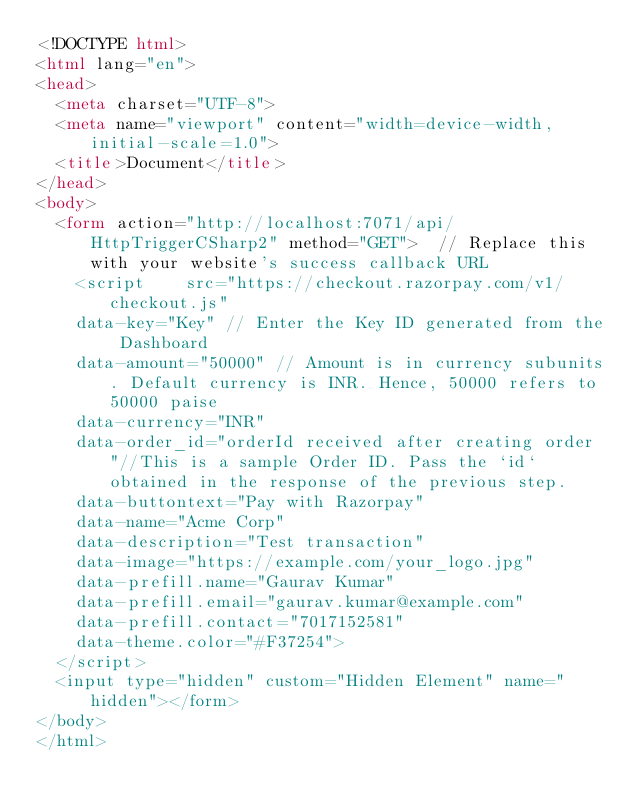Convert code to text. <code><loc_0><loc_0><loc_500><loc_500><_HTML_><!DOCTYPE html>
<html lang="en">
<head>
  <meta charset="UTF-8">
  <meta name="viewport" content="width=device-width, initial-scale=1.0">
  <title>Document</title>
</head>
<body>
  <form action="http://localhost:7071/api/HttpTriggerCSharp2" method="GET">  // Replace this with your website's success callback URL
    <script    src="https://checkout.razorpay.com/v1/checkout.js"    
    data-key="Key" // Enter the Key ID generated from the Dashboard    
    data-amount="50000" // Amount is in currency subunits. Default currency is INR. Hence, 50000 refers to 50000 paise    
    data-currency="INR"    
    data-order_id="orderId received after creating order"//This is a sample Order ID. Pass the `id` obtained in the response of the previous step.    
    data-buttontext="Pay with Razorpay"    
    data-name="Acme Corp"    
    data-description="Test transaction"    
    data-image="https://example.com/your_logo.jpg"    
    data-prefill.name="Gaurav Kumar"    
    data-prefill.email="gaurav.kumar@example.com"    
    data-prefill.contact="7017152581"    
    data-theme.color="#F37254">
  </script>
  <input type="hidden" custom="Hidden Element" name="hidden"></form>
</body>
</html></code> 